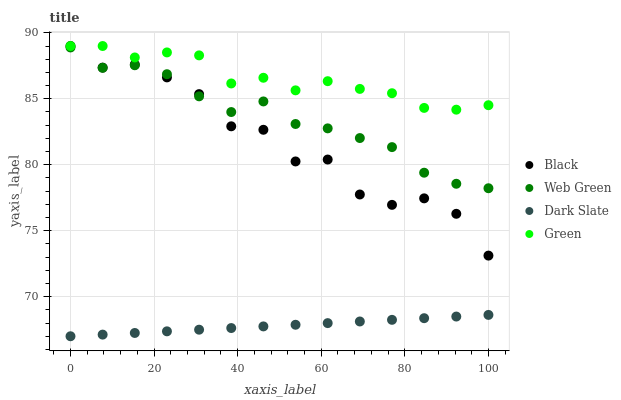Does Dark Slate have the minimum area under the curve?
Answer yes or no. Yes. Does Green have the maximum area under the curve?
Answer yes or no. Yes. Does Black have the minimum area under the curve?
Answer yes or no. No. Does Black have the maximum area under the curve?
Answer yes or no. No. Is Dark Slate the smoothest?
Answer yes or no. Yes. Is Black the roughest?
Answer yes or no. Yes. Is Green the smoothest?
Answer yes or no. No. Is Green the roughest?
Answer yes or no. No. Does Dark Slate have the lowest value?
Answer yes or no. Yes. Does Black have the lowest value?
Answer yes or no. No. Does Black have the highest value?
Answer yes or no. Yes. Does Web Green have the highest value?
Answer yes or no. No. Is Dark Slate less than Green?
Answer yes or no. Yes. Is Web Green greater than Dark Slate?
Answer yes or no. Yes. Does Web Green intersect Black?
Answer yes or no. Yes. Is Web Green less than Black?
Answer yes or no. No. Is Web Green greater than Black?
Answer yes or no. No. Does Dark Slate intersect Green?
Answer yes or no. No. 